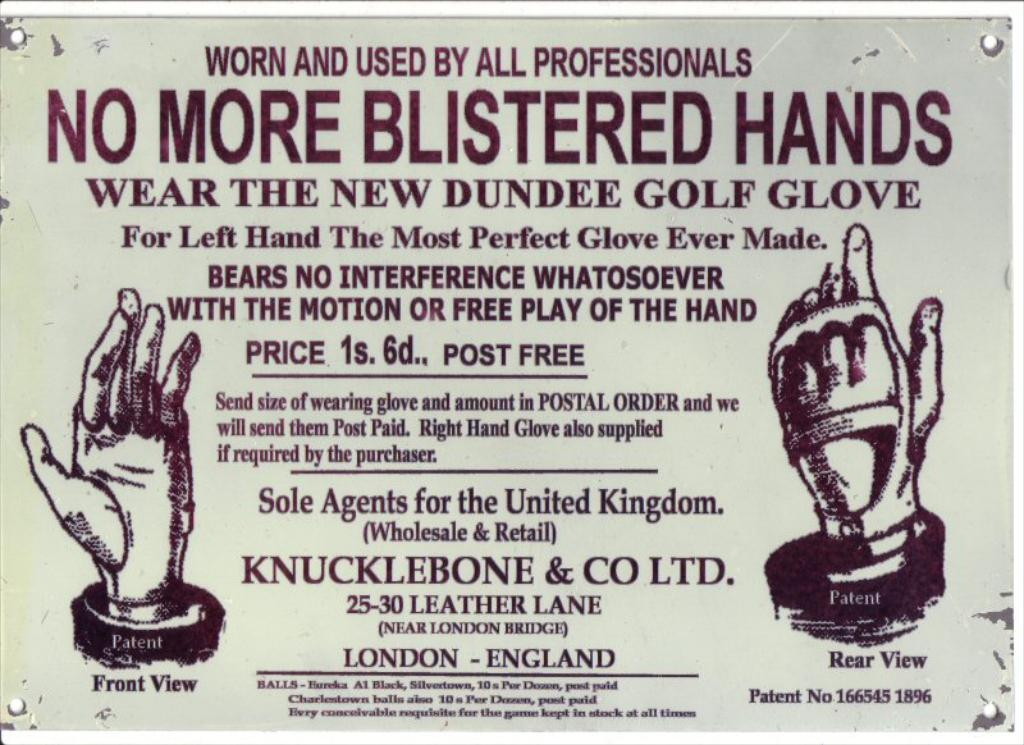<image>
Offer a succinct explanation of the picture presented. An old advertisement of gloves sold in the city of London. 